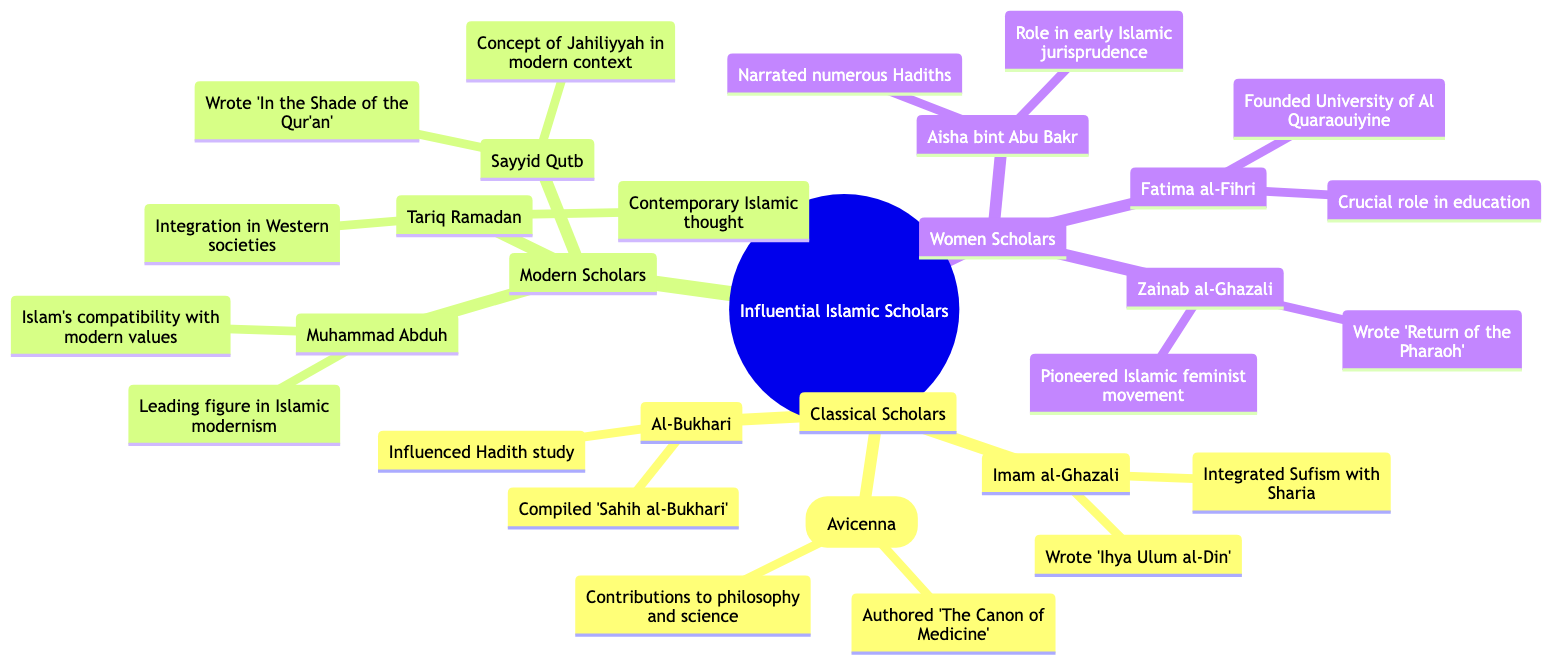What is the central topic of the mind map? The central topic is clearly stated at the root of the diagram as "Influential Islamic Scholars and Their Contributions."
Answer: Influential Islamic Scholars and Their Contributions How many branches are there in the mind map? The main branches listed in the diagram include "Classical Scholars," "Modern Scholars," and "Women Scholars," totaling three branches.
Answer: 3 Name one contribution of Imam al-Ghazali. One contribution mentioned under Imam al-Ghazali is "Wrote 'Ihya Ulum al-Din' (The Revival of the Religious Sciences)."
Answer: Wrote 'Ihya Ulum al-Din' Which scholar is known for compiling 'Sahih al-Bukhari'? The scholar known for compiling 'Sahih al-Bukhari' is Al-Bukhari as shown in the diagram.
Answer: Al-Bukhari What concept did Sayyid Qutb develop in a modern context? The concept developed by Sayyid Qutb in a modern context is "Jahiliyyah."
Answer: Jahiliyyah Which scholar founded the University of Al Quaraouiyine? Fatima al-Fihri is the scholar who founded the University of Al Quaraouiyine in Fez, Morocco.
Answer: Fatima al-Fihri What is Zainab al-Ghazali known for? Zainab al-Ghazali is known for "Pioneering the Islamic feminist movement."
Answer: Pioneered the Islamic feminist movement How many contributions are listed for Ibn Sina (Avicenna)? The diagram lists two contributions for Ibn Sina (Avicenna): "Authored 'The Canon of Medicine'" and "Significant contributions to philosophy and science."
Answer: 2 What role did Aisha bint Abu Bakr play in early Islamic history? Aisha bint Abu Bakr played a significant role in early Islamic history and jurisprudence.
Answer: Role in early Islamic history and jurisprudence 